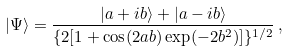<formula> <loc_0><loc_0><loc_500><loc_500>| \Psi \rangle = \frac { | a + i b \rangle + | a - i b \rangle } { \{ 2 [ 1 + \cos ( 2 a b ) \exp ( - 2 b ^ { 2 } ) ] \} ^ { 1 / 2 } } \, ,</formula> 